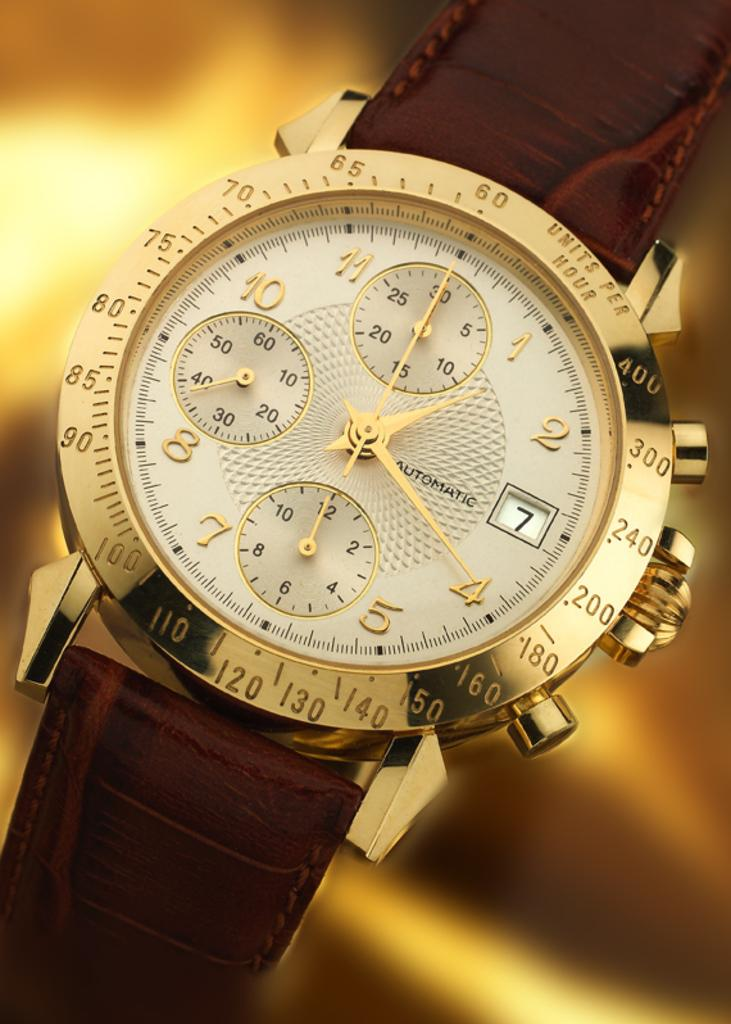<image>
Describe the image concisely. A watch with a leather band displays the day of the month as the 7th. 